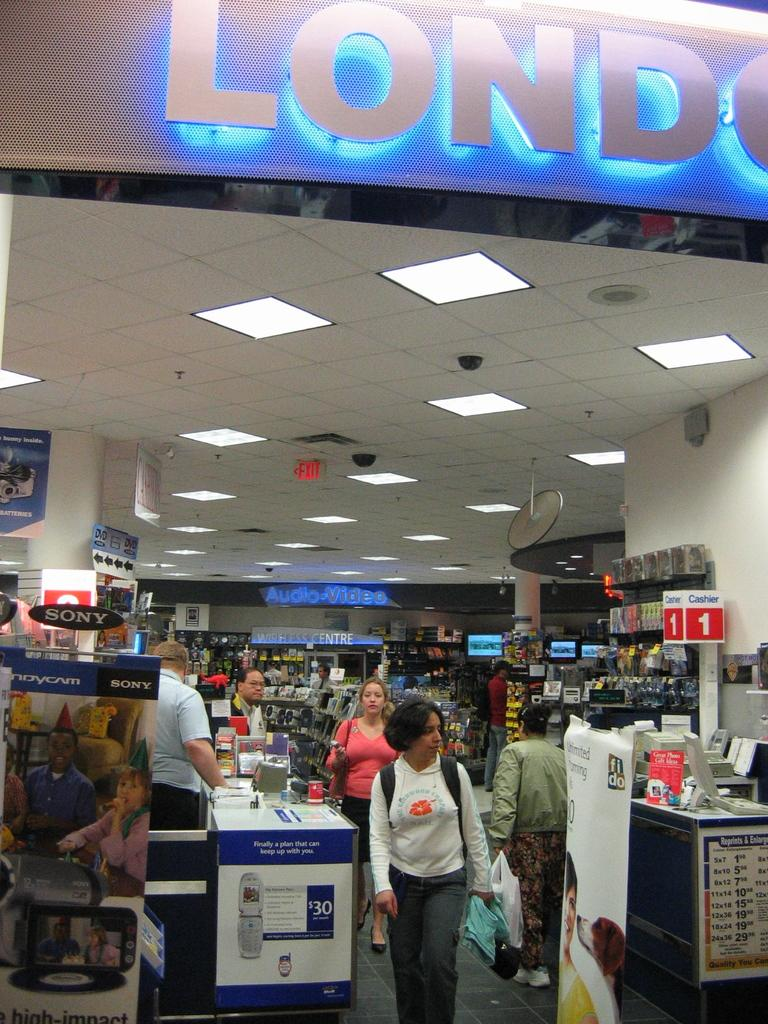<image>
Write a terse but informative summary of the picture. The checkout area of a store with Cashier 1 visible 